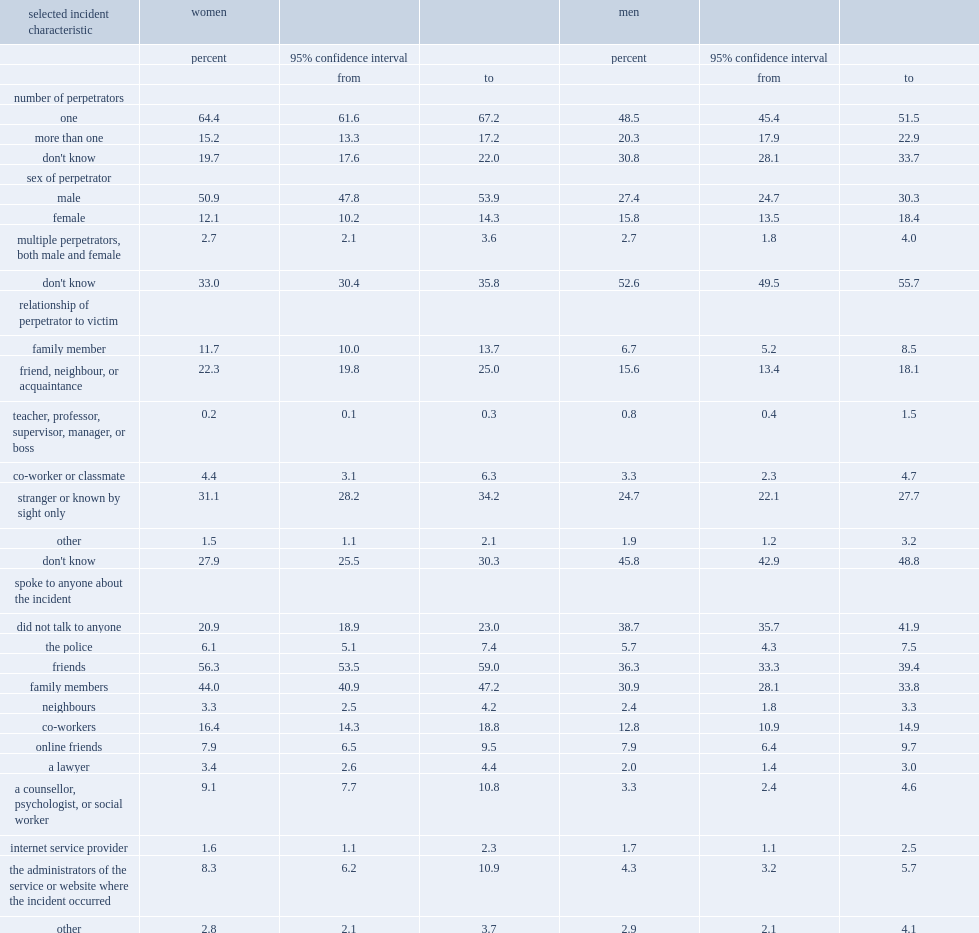Among women, what is the percentage of them who did not know the relationship of the perpetrator to them in the past 12 months of 2018? 27.9. Among women, what is the percentage of them who did not know how many people were responsible to them in the past 12 months of 2018? 19.7. Among women, what is the percentage of them who did not know the sex of the perpetrator in the past 12 months of 2018? 33.0. Among men, what is the percentage of them who did not know the relationship of the perpetrator to them in the past 12 months of 2018? 45.8. Among men, what is the percentage of them who did not know how many people were responsible to them in the past 12 months of 2018? 30.8. Among men, what is the percentage of them who did not know the sex of the perpetrator in the past 12 months of 2018? 52.6. Which gender's proportions of those who did not know the relationship of the perpetrator to them, did not know how many people were responsible, and did not know the sex of the perpetrator were higher? Men. What is the percentage of women who stated that the perpetrator was a stranger in the past 12 months of 2018? 31.1. What is the percentage of men who stated that the perpetrator was a stranger in the past 12 months of 2018? 24.7. Which gender was more likely to speak with friends, family members, co-workers, a counsellor, psychologist, or social worker, the administrator of the service where the incident took place, or a lawyer in the past 12 months of 2018? Women. What is the percentage of women spoke with friends in the past 12 months of 2018? 56.3. What is the percentage of men spoke with friends in the past 12 months of 2018? 36.3. What is the percentage of women spoke with family members in the past 12 months of 2018? 44.0. What is the percentage of men spoke with family members in the past 12 months of 2018? 30.9. What is the percentage of women spoke with co-workers in the past 12 months of 2018? 16.4. What is the percentage of men spoke with co-workers in the past 12 months of 2018? 12.8. What is the percentage of women spoke with a counsellor, psychologist, or social worker in the past 12 months of 2018? 9.1. What is the percentage of men spoke with a counsellor, psychologist, or social worker in the past 12 months of 2018? 3.3. What is the percentage of women spoke with the administrator of the service where the incident took place in the past 12 months of 2018? 8.3. What is the percentage of men spoke with the administrator of the service where the incident took place in the past 12 months of 2018? 4.3. What is the percentage of women spoke with a lawyer in the past 12 months of 2018? 3.4. What is the percentage of men spoke with a lawyer in the past 12 months of 2018? 2.0. In contrast, which gender was considerably more likely than women to state that they did not speak to anybody about the most serious instance in the past 12 months of 2018? Men. What is the percentage of men who stated that they did not speak to anybody about the most serious instance in the past 12 months of 2018? 38.7. What is the percentage of women who stated that they did not speak to anybody about the most serious instance in the past 12 months of 2018? 20.9. 